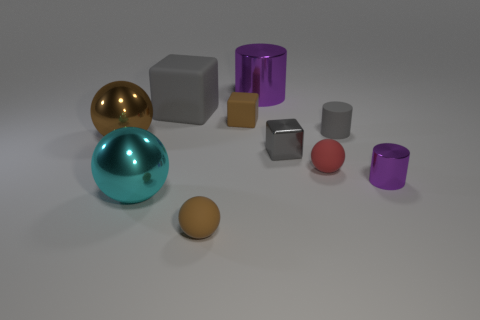Subtract all small brown matte spheres. How many spheres are left? 3 Subtract all green cylinders. How many gray cubes are left? 2 Subtract 1 cylinders. How many cylinders are left? 2 Subtract all red spheres. How many spheres are left? 3 Subtract all purple spheres. Subtract all brown cylinders. How many spheres are left? 4 Subtract all balls. How many objects are left? 6 Add 5 blue shiny objects. How many blue shiny objects exist? 5 Subtract 0 yellow balls. How many objects are left? 10 Subtract all matte cylinders. Subtract all big brown things. How many objects are left? 8 Add 7 gray metallic objects. How many gray metallic objects are left? 8 